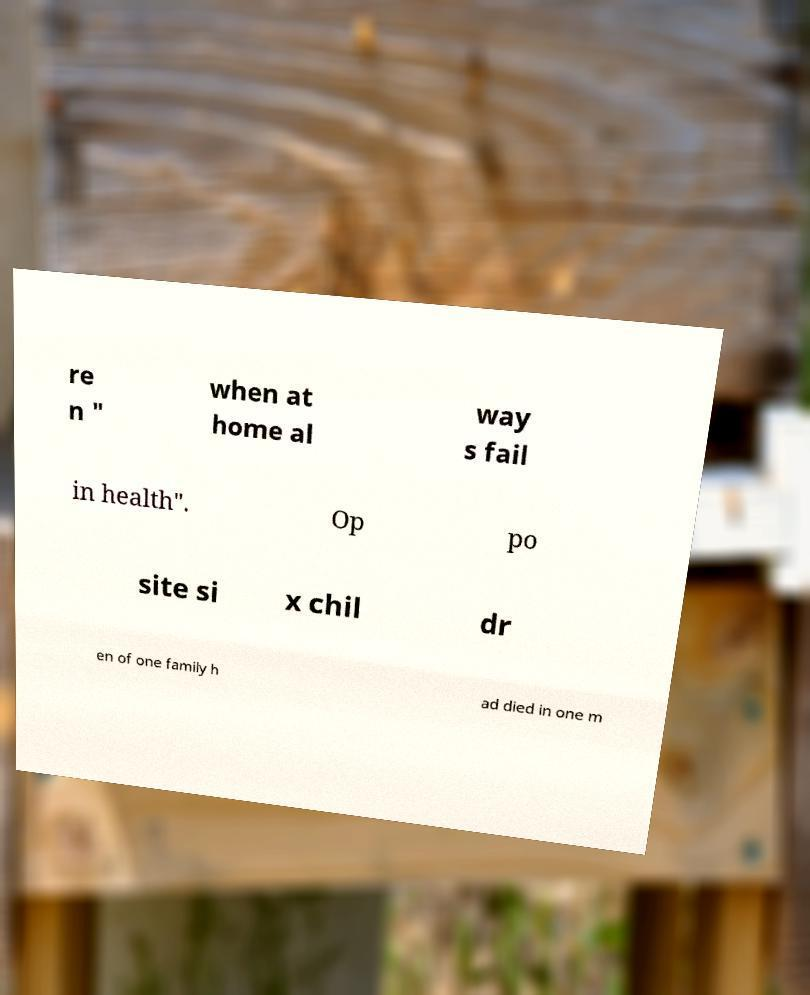There's text embedded in this image that I need extracted. Can you transcribe it verbatim? re n " when at home al way s fail in health". Op po site si x chil dr en of one family h ad died in one m 